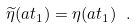Convert formula to latex. <formula><loc_0><loc_0><loc_500><loc_500>\widetilde { \eta } ( a t _ { 1 } ) = \eta ( a t _ { 1 } ) \ .</formula> 